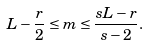Convert formula to latex. <formula><loc_0><loc_0><loc_500><loc_500>L - \frac { r } { 2 } \leq m \leq \frac { s L - r } { s - 2 } .</formula> 